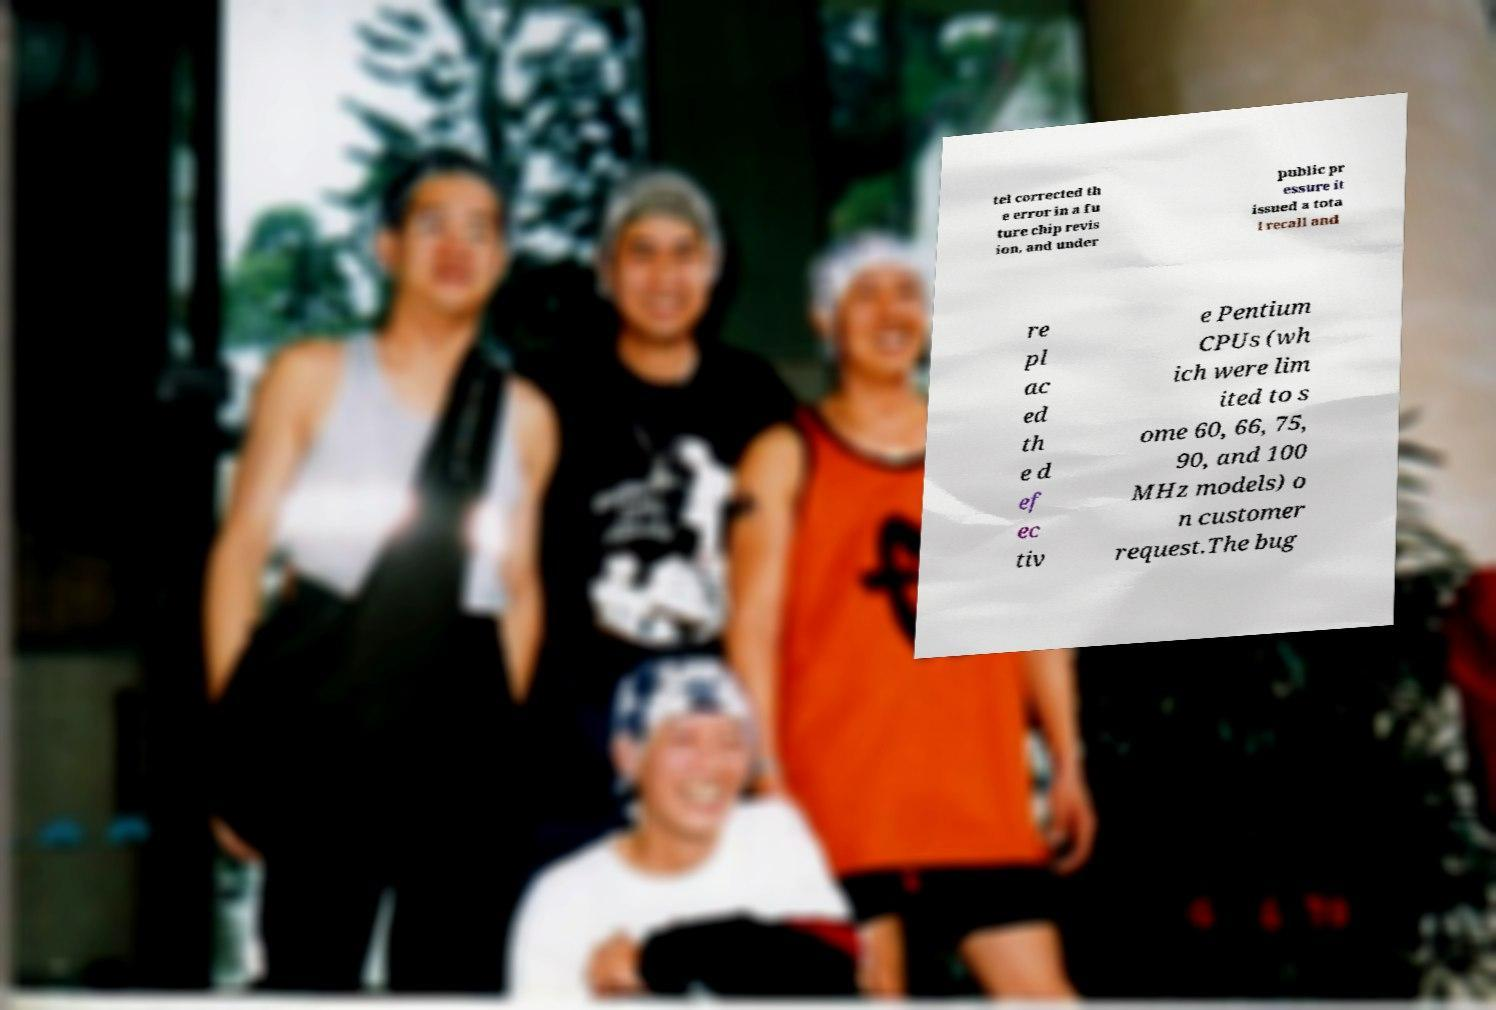Please identify and transcribe the text found in this image. tel corrected th e error in a fu ture chip revis ion, and under public pr essure it issued a tota l recall and re pl ac ed th e d ef ec tiv e Pentium CPUs (wh ich were lim ited to s ome 60, 66, 75, 90, and 100 MHz models) o n customer request.The bug 